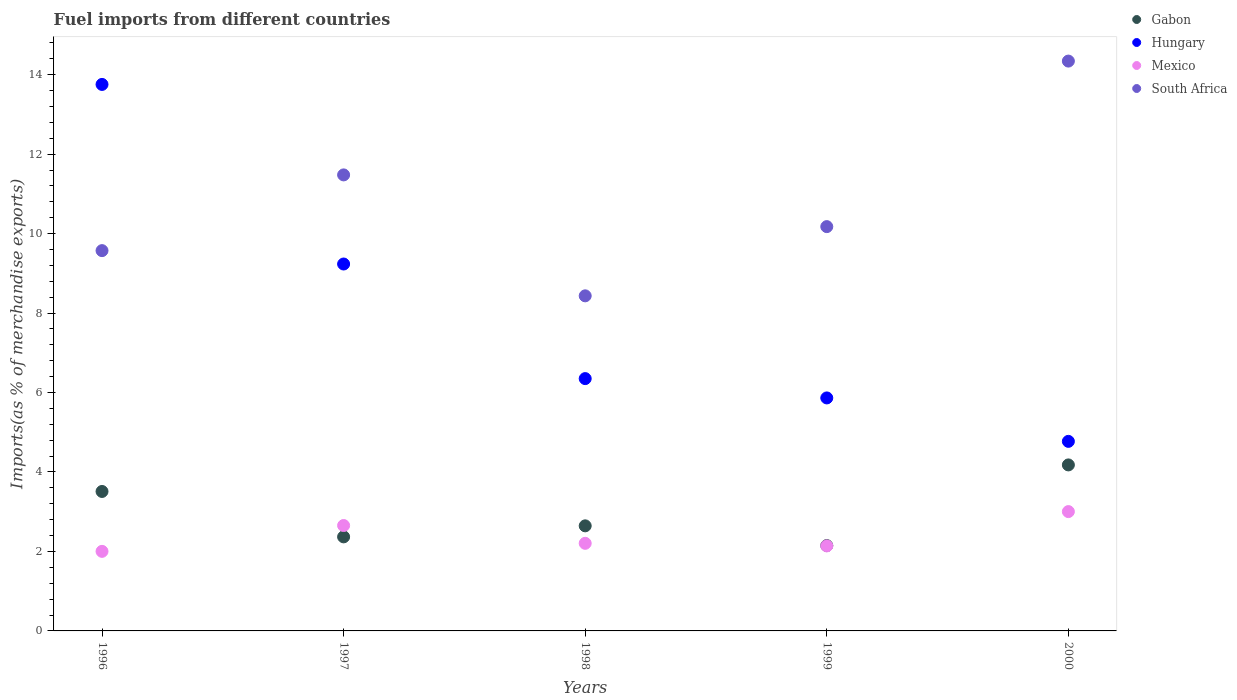Is the number of dotlines equal to the number of legend labels?
Your answer should be very brief. Yes. What is the percentage of imports to different countries in Gabon in 2000?
Offer a terse response. 4.18. Across all years, what is the maximum percentage of imports to different countries in Hungary?
Provide a short and direct response. 13.76. Across all years, what is the minimum percentage of imports to different countries in South Africa?
Make the answer very short. 8.43. What is the total percentage of imports to different countries in Mexico in the graph?
Offer a very short reply. 12. What is the difference between the percentage of imports to different countries in Mexico in 1996 and that in 1997?
Your answer should be compact. -0.65. What is the difference between the percentage of imports to different countries in Gabon in 1999 and the percentage of imports to different countries in Hungary in 2000?
Your answer should be compact. -2.62. What is the average percentage of imports to different countries in South Africa per year?
Ensure brevity in your answer.  10.8. In the year 2000, what is the difference between the percentage of imports to different countries in Mexico and percentage of imports to different countries in Hungary?
Ensure brevity in your answer.  -1.77. In how many years, is the percentage of imports to different countries in Gabon greater than 1.6 %?
Provide a succinct answer. 5. What is the ratio of the percentage of imports to different countries in Gabon in 1999 to that in 2000?
Your answer should be very brief. 0.51. What is the difference between the highest and the second highest percentage of imports to different countries in Gabon?
Offer a terse response. 0.67. What is the difference between the highest and the lowest percentage of imports to different countries in Gabon?
Provide a succinct answer. 2.03. In how many years, is the percentage of imports to different countries in South Africa greater than the average percentage of imports to different countries in South Africa taken over all years?
Provide a succinct answer. 2. Is the sum of the percentage of imports to different countries in Mexico in 1996 and 1998 greater than the maximum percentage of imports to different countries in Gabon across all years?
Offer a very short reply. Yes. Is it the case that in every year, the sum of the percentage of imports to different countries in Hungary and percentage of imports to different countries in South Africa  is greater than the sum of percentage of imports to different countries in Mexico and percentage of imports to different countries in Gabon?
Offer a very short reply. No. Is the percentage of imports to different countries in Mexico strictly less than the percentage of imports to different countries in Hungary over the years?
Your answer should be very brief. Yes. Are the values on the major ticks of Y-axis written in scientific E-notation?
Provide a short and direct response. No. Does the graph contain any zero values?
Provide a short and direct response. No. Does the graph contain grids?
Offer a very short reply. No. How are the legend labels stacked?
Ensure brevity in your answer.  Vertical. What is the title of the graph?
Provide a succinct answer. Fuel imports from different countries. What is the label or title of the Y-axis?
Give a very brief answer. Imports(as % of merchandise exports). What is the Imports(as % of merchandise exports) of Gabon in 1996?
Provide a short and direct response. 3.51. What is the Imports(as % of merchandise exports) of Hungary in 1996?
Your answer should be very brief. 13.76. What is the Imports(as % of merchandise exports) in Mexico in 1996?
Provide a short and direct response. 2. What is the Imports(as % of merchandise exports) of South Africa in 1996?
Make the answer very short. 9.57. What is the Imports(as % of merchandise exports) in Gabon in 1997?
Provide a succinct answer. 2.37. What is the Imports(as % of merchandise exports) in Hungary in 1997?
Make the answer very short. 9.24. What is the Imports(as % of merchandise exports) in Mexico in 1997?
Ensure brevity in your answer.  2.65. What is the Imports(as % of merchandise exports) of South Africa in 1997?
Provide a short and direct response. 11.48. What is the Imports(as % of merchandise exports) in Gabon in 1998?
Keep it short and to the point. 2.64. What is the Imports(as % of merchandise exports) in Hungary in 1998?
Your response must be concise. 6.35. What is the Imports(as % of merchandise exports) in Mexico in 1998?
Your answer should be very brief. 2.2. What is the Imports(as % of merchandise exports) of South Africa in 1998?
Provide a short and direct response. 8.43. What is the Imports(as % of merchandise exports) of Gabon in 1999?
Offer a terse response. 2.15. What is the Imports(as % of merchandise exports) in Hungary in 1999?
Your answer should be very brief. 5.86. What is the Imports(as % of merchandise exports) in Mexico in 1999?
Your answer should be compact. 2.14. What is the Imports(as % of merchandise exports) in South Africa in 1999?
Make the answer very short. 10.18. What is the Imports(as % of merchandise exports) of Gabon in 2000?
Offer a very short reply. 4.18. What is the Imports(as % of merchandise exports) in Hungary in 2000?
Your answer should be very brief. 4.77. What is the Imports(as % of merchandise exports) of Mexico in 2000?
Make the answer very short. 3. What is the Imports(as % of merchandise exports) in South Africa in 2000?
Offer a very short reply. 14.34. Across all years, what is the maximum Imports(as % of merchandise exports) in Gabon?
Your answer should be compact. 4.18. Across all years, what is the maximum Imports(as % of merchandise exports) of Hungary?
Keep it short and to the point. 13.76. Across all years, what is the maximum Imports(as % of merchandise exports) in Mexico?
Make the answer very short. 3. Across all years, what is the maximum Imports(as % of merchandise exports) of South Africa?
Your answer should be very brief. 14.34. Across all years, what is the minimum Imports(as % of merchandise exports) of Gabon?
Keep it short and to the point. 2.15. Across all years, what is the minimum Imports(as % of merchandise exports) in Hungary?
Your answer should be compact. 4.77. Across all years, what is the minimum Imports(as % of merchandise exports) of Mexico?
Keep it short and to the point. 2. Across all years, what is the minimum Imports(as % of merchandise exports) in South Africa?
Offer a very short reply. 8.43. What is the total Imports(as % of merchandise exports) in Gabon in the graph?
Provide a short and direct response. 14.85. What is the total Imports(as % of merchandise exports) in Hungary in the graph?
Ensure brevity in your answer.  39.98. What is the total Imports(as % of merchandise exports) of Mexico in the graph?
Offer a very short reply. 12. What is the total Imports(as % of merchandise exports) of South Africa in the graph?
Keep it short and to the point. 54. What is the difference between the Imports(as % of merchandise exports) of Gabon in 1996 and that in 1997?
Make the answer very short. 1.14. What is the difference between the Imports(as % of merchandise exports) in Hungary in 1996 and that in 1997?
Your answer should be compact. 4.52. What is the difference between the Imports(as % of merchandise exports) of Mexico in 1996 and that in 1997?
Ensure brevity in your answer.  -0.65. What is the difference between the Imports(as % of merchandise exports) of South Africa in 1996 and that in 1997?
Give a very brief answer. -1.91. What is the difference between the Imports(as % of merchandise exports) of Gabon in 1996 and that in 1998?
Provide a succinct answer. 0.87. What is the difference between the Imports(as % of merchandise exports) in Hungary in 1996 and that in 1998?
Offer a very short reply. 7.4. What is the difference between the Imports(as % of merchandise exports) of Mexico in 1996 and that in 1998?
Your answer should be compact. -0.2. What is the difference between the Imports(as % of merchandise exports) of South Africa in 1996 and that in 1998?
Make the answer very short. 1.14. What is the difference between the Imports(as % of merchandise exports) of Gabon in 1996 and that in 1999?
Give a very brief answer. 1.36. What is the difference between the Imports(as % of merchandise exports) of Hungary in 1996 and that in 1999?
Your answer should be very brief. 7.89. What is the difference between the Imports(as % of merchandise exports) in Mexico in 1996 and that in 1999?
Your answer should be very brief. -0.14. What is the difference between the Imports(as % of merchandise exports) of South Africa in 1996 and that in 1999?
Offer a terse response. -0.6. What is the difference between the Imports(as % of merchandise exports) in Gabon in 1996 and that in 2000?
Offer a terse response. -0.67. What is the difference between the Imports(as % of merchandise exports) in Hungary in 1996 and that in 2000?
Offer a very short reply. 8.98. What is the difference between the Imports(as % of merchandise exports) of Mexico in 1996 and that in 2000?
Provide a short and direct response. -1. What is the difference between the Imports(as % of merchandise exports) of South Africa in 1996 and that in 2000?
Provide a succinct answer. -4.77. What is the difference between the Imports(as % of merchandise exports) in Gabon in 1997 and that in 1998?
Keep it short and to the point. -0.28. What is the difference between the Imports(as % of merchandise exports) in Hungary in 1997 and that in 1998?
Offer a terse response. 2.88. What is the difference between the Imports(as % of merchandise exports) of Mexico in 1997 and that in 1998?
Make the answer very short. 0.45. What is the difference between the Imports(as % of merchandise exports) of South Africa in 1997 and that in 1998?
Offer a very short reply. 3.04. What is the difference between the Imports(as % of merchandise exports) in Gabon in 1997 and that in 1999?
Your answer should be very brief. 0.22. What is the difference between the Imports(as % of merchandise exports) in Hungary in 1997 and that in 1999?
Give a very brief answer. 3.37. What is the difference between the Imports(as % of merchandise exports) of Mexico in 1997 and that in 1999?
Make the answer very short. 0.51. What is the difference between the Imports(as % of merchandise exports) of South Africa in 1997 and that in 1999?
Make the answer very short. 1.3. What is the difference between the Imports(as % of merchandise exports) in Gabon in 1997 and that in 2000?
Make the answer very short. -1.81. What is the difference between the Imports(as % of merchandise exports) in Hungary in 1997 and that in 2000?
Make the answer very short. 4.46. What is the difference between the Imports(as % of merchandise exports) in Mexico in 1997 and that in 2000?
Your response must be concise. -0.35. What is the difference between the Imports(as % of merchandise exports) of South Africa in 1997 and that in 2000?
Make the answer very short. -2.86. What is the difference between the Imports(as % of merchandise exports) in Gabon in 1998 and that in 1999?
Offer a very short reply. 0.5. What is the difference between the Imports(as % of merchandise exports) of Hungary in 1998 and that in 1999?
Offer a terse response. 0.49. What is the difference between the Imports(as % of merchandise exports) of Mexico in 1998 and that in 1999?
Provide a short and direct response. 0.07. What is the difference between the Imports(as % of merchandise exports) of South Africa in 1998 and that in 1999?
Your answer should be compact. -1.74. What is the difference between the Imports(as % of merchandise exports) in Gabon in 1998 and that in 2000?
Offer a terse response. -1.53. What is the difference between the Imports(as % of merchandise exports) in Hungary in 1998 and that in 2000?
Offer a terse response. 1.58. What is the difference between the Imports(as % of merchandise exports) of Mexico in 1998 and that in 2000?
Provide a short and direct response. -0.8. What is the difference between the Imports(as % of merchandise exports) in South Africa in 1998 and that in 2000?
Make the answer very short. -5.91. What is the difference between the Imports(as % of merchandise exports) of Gabon in 1999 and that in 2000?
Provide a short and direct response. -2.03. What is the difference between the Imports(as % of merchandise exports) in Hungary in 1999 and that in 2000?
Provide a succinct answer. 1.09. What is the difference between the Imports(as % of merchandise exports) in Mexico in 1999 and that in 2000?
Give a very brief answer. -0.86. What is the difference between the Imports(as % of merchandise exports) of South Africa in 1999 and that in 2000?
Offer a terse response. -4.17. What is the difference between the Imports(as % of merchandise exports) of Gabon in 1996 and the Imports(as % of merchandise exports) of Hungary in 1997?
Your response must be concise. -5.72. What is the difference between the Imports(as % of merchandise exports) of Gabon in 1996 and the Imports(as % of merchandise exports) of Mexico in 1997?
Ensure brevity in your answer.  0.86. What is the difference between the Imports(as % of merchandise exports) of Gabon in 1996 and the Imports(as % of merchandise exports) of South Africa in 1997?
Provide a succinct answer. -7.97. What is the difference between the Imports(as % of merchandise exports) of Hungary in 1996 and the Imports(as % of merchandise exports) of Mexico in 1997?
Your answer should be very brief. 11.1. What is the difference between the Imports(as % of merchandise exports) of Hungary in 1996 and the Imports(as % of merchandise exports) of South Africa in 1997?
Provide a succinct answer. 2.28. What is the difference between the Imports(as % of merchandise exports) of Mexico in 1996 and the Imports(as % of merchandise exports) of South Africa in 1997?
Offer a terse response. -9.48. What is the difference between the Imports(as % of merchandise exports) of Gabon in 1996 and the Imports(as % of merchandise exports) of Hungary in 1998?
Ensure brevity in your answer.  -2.84. What is the difference between the Imports(as % of merchandise exports) of Gabon in 1996 and the Imports(as % of merchandise exports) of Mexico in 1998?
Your response must be concise. 1.31. What is the difference between the Imports(as % of merchandise exports) in Gabon in 1996 and the Imports(as % of merchandise exports) in South Africa in 1998?
Keep it short and to the point. -4.92. What is the difference between the Imports(as % of merchandise exports) in Hungary in 1996 and the Imports(as % of merchandise exports) in Mexico in 1998?
Offer a very short reply. 11.55. What is the difference between the Imports(as % of merchandise exports) of Hungary in 1996 and the Imports(as % of merchandise exports) of South Africa in 1998?
Ensure brevity in your answer.  5.32. What is the difference between the Imports(as % of merchandise exports) in Mexico in 1996 and the Imports(as % of merchandise exports) in South Africa in 1998?
Your answer should be very brief. -6.43. What is the difference between the Imports(as % of merchandise exports) in Gabon in 1996 and the Imports(as % of merchandise exports) in Hungary in 1999?
Keep it short and to the point. -2.35. What is the difference between the Imports(as % of merchandise exports) in Gabon in 1996 and the Imports(as % of merchandise exports) in Mexico in 1999?
Your answer should be compact. 1.37. What is the difference between the Imports(as % of merchandise exports) of Gabon in 1996 and the Imports(as % of merchandise exports) of South Africa in 1999?
Provide a short and direct response. -6.67. What is the difference between the Imports(as % of merchandise exports) in Hungary in 1996 and the Imports(as % of merchandise exports) in Mexico in 1999?
Keep it short and to the point. 11.62. What is the difference between the Imports(as % of merchandise exports) in Hungary in 1996 and the Imports(as % of merchandise exports) in South Africa in 1999?
Provide a short and direct response. 3.58. What is the difference between the Imports(as % of merchandise exports) in Mexico in 1996 and the Imports(as % of merchandise exports) in South Africa in 1999?
Make the answer very short. -8.17. What is the difference between the Imports(as % of merchandise exports) in Gabon in 1996 and the Imports(as % of merchandise exports) in Hungary in 2000?
Make the answer very short. -1.26. What is the difference between the Imports(as % of merchandise exports) in Gabon in 1996 and the Imports(as % of merchandise exports) in Mexico in 2000?
Provide a succinct answer. 0.51. What is the difference between the Imports(as % of merchandise exports) in Gabon in 1996 and the Imports(as % of merchandise exports) in South Africa in 2000?
Ensure brevity in your answer.  -10.83. What is the difference between the Imports(as % of merchandise exports) of Hungary in 1996 and the Imports(as % of merchandise exports) of Mexico in 2000?
Ensure brevity in your answer.  10.75. What is the difference between the Imports(as % of merchandise exports) in Hungary in 1996 and the Imports(as % of merchandise exports) in South Africa in 2000?
Your response must be concise. -0.59. What is the difference between the Imports(as % of merchandise exports) of Mexico in 1996 and the Imports(as % of merchandise exports) of South Africa in 2000?
Offer a very short reply. -12.34. What is the difference between the Imports(as % of merchandise exports) in Gabon in 1997 and the Imports(as % of merchandise exports) in Hungary in 1998?
Your answer should be compact. -3.98. What is the difference between the Imports(as % of merchandise exports) in Gabon in 1997 and the Imports(as % of merchandise exports) in Mexico in 1998?
Keep it short and to the point. 0.16. What is the difference between the Imports(as % of merchandise exports) of Gabon in 1997 and the Imports(as % of merchandise exports) of South Africa in 1998?
Make the answer very short. -6.07. What is the difference between the Imports(as % of merchandise exports) of Hungary in 1997 and the Imports(as % of merchandise exports) of Mexico in 1998?
Your response must be concise. 7.03. What is the difference between the Imports(as % of merchandise exports) in Hungary in 1997 and the Imports(as % of merchandise exports) in South Africa in 1998?
Keep it short and to the point. 0.8. What is the difference between the Imports(as % of merchandise exports) of Mexico in 1997 and the Imports(as % of merchandise exports) of South Africa in 1998?
Your answer should be very brief. -5.78. What is the difference between the Imports(as % of merchandise exports) of Gabon in 1997 and the Imports(as % of merchandise exports) of Hungary in 1999?
Keep it short and to the point. -3.5. What is the difference between the Imports(as % of merchandise exports) in Gabon in 1997 and the Imports(as % of merchandise exports) in Mexico in 1999?
Give a very brief answer. 0.23. What is the difference between the Imports(as % of merchandise exports) of Gabon in 1997 and the Imports(as % of merchandise exports) of South Africa in 1999?
Make the answer very short. -7.81. What is the difference between the Imports(as % of merchandise exports) in Hungary in 1997 and the Imports(as % of merchandise exports) in Mexico in 1999?
Keep it short and to the point. 7.1. What is the difference between the Imports(as % of merchandise exports) in Hungary in 1997 and the Imports(as % of merchandise exports) in South Africa in 1999?
Your answer should be compact. -0.94. What is the difference between the Imports(as % of merchandise exports) in Mexico in 1997 and the Imports(as % of merchandise exports) in South Africa in 1999?
Offer a very short reply. -7.52. What is the difference between the Imports(as % of merchandise exports) of Gabon in 1997 and the Imports(as % of merchandise exports) of Hungary in 2000?
Ensure brevity in your answer.  -2.4. What is the difference between the Imports(as % of merchandise exports) in Gabon in 1997 and the Imports(as % of merchandise exports) in Mexico in 2000?
Provide a succinct answer. -0.64. What is the difference between the Imports(as % of merchandise exports) in Gabon in 1997 and the Imports(as % of merchandise exports) in South Africa in 2000?
Your answer should be very brief. -11.98. What is the difference between the Imports(as % of merchandise exports) in Hungary in 1997 and the Imports(as % of merchandise exports) in Mexico in 2000?
Your response must be concise. 6.23. What is the difference between the Imports(as % of merchandise exports) of Hungary in 1997 and the Imports(as % of merchandise exports) of South Africa in 2000?
Provide a succinct answer. -5.11. What is the difference between the Imports(as % of merchandise exports) of Mexico in 1997 and the Imports(as % of merchandise exports) of South Africa in 2000?
Provide a succinct answer. -11.69. What is the difference between the Imports(as % of merchandise exports) in Gabon in 1998 and the Imports(as % of merchandise exports) in Hungary in 1999?
Your answer should be very brief. -3.22. What is the difference between the Imports(as % of merchandise exports) of Gabon in 1998 and the Imports(as % of merchandise exports) of Mexico in 1999?
Ensure brevity in your answer.  0.51. What is the difference between the Imports(as % of merchandise exports) in Gabon in 1998 and the Imports(as % of merchandise exports) in South Africa in 1999?
Your answer should be compact. -7.53. What is the difference between the Imports(as % of merchandise exports) in Hungary in 1998 and the Imports(as % of merchandise exports) in Mexico in 1999?
Keep it short and to the point. 4.21. What is the difference between the Imports(as % of merchandise exports) in Hungary in 1998 and the Imports(as % of merchandise exports) in South Africa in 1999?
Keep it short and to the point. -3.83. What is the difference between the Imports(as % of merchandise exports) in Mexico in 1998 and the Imports(as % of merchandise exports) in South Africa in 1999?
Your response must be concise. -7.97. What is the difference between the Imports(as % of merchandise exports) in Gabon in 1998 and the Imports(as % of merchandise exports) in Hungary in 2000?
Keep it short and to the point. -2.13. What is the difference between the Imports(as % of merchandise exports) of Gabon in 1998 and the Imports(as % of merchandise exports) of Mexico in 2000?
Offer a terse response. -0.36. What is the difference between the Imports(as % of merchandise exports) of Gabon in 1998 and the Imports(as % of merchandise exports) of South Africa in 2000?
Ensure brevity in your answer.  -11.7. What is the difference between the Imports(as % of merchandise exports) of Hungary in 1998 and the Imports(as % of merchandise exports) of Mexico in 2000?
Offer a terse response. 3.35. What is the difference between the Imports(as % of merchandise exports) of Hungary in 1998 and the Imports(as % of merchandise exports) of South Africa in 2000?
Give a very brief answer. -7.99. What is the difference between the Imports(as % of merchandise exports) in Mexico in 1998 and the Imports(as % of merchandise exports) in South Africa in 2000?
Give a very brief answer. -12.14. What is the difference between the Imports(as % of merchandise exports) of Gabon in 1999 and the Imports(as % of merchandise exports) of Hungary in 2000?
Make the answer very short. -2.62. What is the difference between the Imports(as % of merchandise exports) in Gabon in 1999 and the Imports(as % of merchandise exports) in Mexico in 2000?
Keep it short and to the point. -0.86. What is the difference between the Imports(as % of merchandise exports) in Gabon in 1999 and the Imports(as % of merchandise exports) in South Africa in 2000?
Your answer should be very brief. -12.19. What is the difference between the Imports(as % of merchandise exports) in Hungary in 1999 and the Imports(as % of merchandise exports) in Mexico in 2000?
Ensure brevity in your answer.  2.86. What is the difference between the Imports(as % of merchandise exports) in Hungary in 1999 and the Imports(as % of merchandise exports) in South Africa in 2000?
Make the answer very short. -8.48. What is the difference between the Imports(as % of merchandise exports) in Mexico in 1999 and the Imports(as % of merchandise exports) in South Africa in 2000?
Your answer should be compact. -12.2. What is the average Imports(as % of merchandise exports) of Gabon per year?
Provide a succinct answer. 2.97. What is the average Imports(as % of merchandise exports) of Hungary per year?
Your answer should be very brief. 8. What is the average Imports(as % of merchandise exports) of Mexico per year?
Keep it short and to the point. 2.4. What is the average Imports(as % of merchandise exports) in South Africa per year?
Provide a succinct answer. 10.8. In the year 1996, what is the difference between the Imports(as % of merchandise exports) of Gabon and Imports(as % of merchandise exports) of Hungary?
Ensure brevity in your answer.  -10.24. In the year 1996, what is the difference between the Imports(as % of merchandise exports) in Gabon and Imports(as % of merchandise exports) in Mexico?
Provide a short and direct response. 1.51. In the year 1996, what is the difference between the Imports(as % of merchandise exports) in Gabon and Imports(as % of merchandise exports) in South Africa?
Make the answer very short. -6.06. In the year 1996, what is the difference between the Imports(as % of merchandise exports) of Hungary and Imports(as % of merchandise exports) of Mexico?
Your answer should be compact. 11.75. In the year 1996, what is the difference between the Imports(as % of merchandise exports) in Hungary and Imports(as % of merchandise exports) in South Africa?
Your answer should be very brief. 4.18. In the year 1996, what is the difference between the Imports(as % of merchandise exports) of Mexico and Imports(as % of merchandise exports) of South Africa?
Offer a very short reply. -7.57. In the year 1997, what is the difference between the Imports(as % of merchandise exports) in Gabon and Imports(as % of merchandise exports) in Hungary?
Offer a very short reply. -6.87. In the year 1997, what is the difference between the Imports(as % of merchandise exports) in Gabon and Imports(as % of merchandise exports) in Mexico?
Ensure brevity in your answer.  -0.29. In the year 1997, what is the difference between the Imports(as % of merchandise exports) in Gabon and Imports(as % of merchandise exports) in South Africa?
Give a very brief answer. -9.11. In the year 1997, what is the difference between the Imports(as % of merchandise exports) of Hungary and Imports(as % of merchandise exports) of Mexico?
Offer a terse response. 6.58. In the year 1997, what is the difference between the Imports(as % of merchandise exports) in Hungary and Imports(as % of merchandise exports) in South Africa?
Your answer should be compact. -2.24. In the year 1997, what is the difference between the Imports(as % of merchandise exports) of Mexico and Imports(as % of merchandise exports) of South Africa?
Give a very brief answer. -8.82. In the year 1998, what is the difference between the Imports(as % of merchandise exports) of Gabon and Imports(as % of merchandise exports) of Hungary?
Ensure brevity in your answer.  -3.71. In the year 1998, what is the difference between the Imports(as % of merchandise exports) in Gabon and Imports(as % of merchandise exports) in Mexico?
Offer a very short reply. 0.44. In the year 1998, what is the difference between the Imports(as % of merchandise exports) in Gabon and Imports(as % of merchandise exports) in South Africa?
Your answer should be very brief. -5.79. In the year 1998, what is the difference between the Imports(as % of merchandise exports) in Hungary and Imports(as % of merchandise exports) in Mexico?
Ensure brevity in your answer.  4.15. In the year 1998, what is the difference between the Imports(as % of merchandise exports) of Hungary and Imports(as % of merchandise exports) of South Africa?
Your response must be concise. -2.08. In the year 1998, what is the difference between the Imports(as % of merchandise exports) in Mexico and Imports(as % of merchandise exports) in South Africa?
Give a very brief answer. -6.23. In the year 1999, what is the difference between the Imports(as % of merchandise exports) in Gabon and Imports(as % of merchandise exports) in Hungary?
Your answer should be compact. -3.72. In the year 1999, what is the difference between the Imports(as % of merchandise exports) of Gabon and Imports(as % of merchandise exports) of Mexico?
Your answer should be compact. 0.01. In the year 1999, what is the difference between the Imports(as % of merchandise exports) in Gabon and Imports(as % of merchandise exports) in South Africa?
Make the answer very short. -8.03. In the year 1999, what is the difference between the Imports(as % of merchandise exports) in Hungary and Imports(as % of merchandise exports) in Mexico?
Offer a terse response. 3.72. In the year 1999, what is the difference between the Imports(as % of merchandise exports) in Hungary and Imports(as % of merchandise exports) in South Africa?
Offer a terse response. -4.31. In the year 1999, what is the difference between the Imports(as % of merchandise exports) in Mexico and Imports(as % of merchandise exports) in South Africa?
Your answer should be very brief. -8.04. In the year 2000, what is the difference between the Imports(as % of merchandise exports) of Gabon and Imports(as % of merchandise exports) of Hungary?
Offer a very short reply. -0.59. In the year 2000, what is the difference between the Imports(as % of merchandise exports) in Gabon and Imports(as % of merchandise exports) in Mexico?
Your answer should be compact. 1.17. In the year 2000, what is the difference between the Imports(as % of merchandise exports) of Gabon and Imports(as % of merchandise exports) of South Africa?
Your response must be concise. -10.16. In the year 2000, what is the difference between the Imports(as % of merchandise exports) in Hungary and Imports(as % of merchandise exports) in Mexico?
Make the answer very short. 1.77. In the year 2000, what is the difference between the Imports(as % of merchandise exports) in Hungary and Imports(as % of merchandise exports) in South Africa?
Offer a terse response. -9.57. In the year 2000, what is the difference between the Imports(as % of merchandise exports) in Mexico and Imports(as % of merchandise exports) in South Africa?
Your response must be concise. -11.34. What is the ratio of the Imports(as % of merchandise exports) in Gabon in 1996 to that in 1997?
Your response must be concise. 1.48. What is the ratio of the Imports(as % of merchandise exports) in Hungary in 1996 to that in 1997?
Offer a very short reply. 1.49. What is the ratio of the Imports(as % of merchandise exports) of Mexico in 1996 to that in 1997?
Your response must be concise. 0.75. What is the ratio of the Imports(as % of merchandise exports) of South Africa in 1996 to that in 1997?
Your answer should be very brief. 0.83. What is the ratio of the Imports(as % of merchandise exports) of Gabon in 1996 to that in 1998?
Make the answer very short. 1.33. What is the ratio of the Imports(as % of merchandise exports) of Hungary in 1996 to that in 1998?
Your response must be concise. 2.17. What is the ratio of the Imports(as % of merchandise exports) of Mexico in 1996 to that in 1998?
Ensure brevity in your answer.  0.91. What is the ratio of the Imports(as % of merchandise exports) of South Africa in 1996 to that in 1998?
Keep it short and to the point. 1.13. What is the ratio of the Imports(as % of merchandise exports) in Gabon in 1996 to that in 1999?
Keep it short and to the point. 1.63. What is the ratio of the Imports(as % of merchandise exports) in Hungary in 1996 to that in 1999?
Keep it short and to the point. 2.35. What is the ratio of the Imports(as % of merchandise exports) in Mexico in 1996 to that in 1999?
Your answer should be very brief. 0.94. What is the ratio of the Imports(as % of merchandise exports) of South Africa in 1996 to that in 1999?
Your answer should be compact. 0.94. What is the ratio of the Imports(as % of merchandise exports) of Gabon in 1996 to that in 2000?
Keep it short and to the point. 0.84. What is the ratio of the Imports(as % of merchandise exports) in Hungary in 1996 to that in 2000?
Your answer should be compact. 2.88. What is the ratio of the Imports(as % of merchandise exports) in Mexico in 1996 to that in 2000?
Ensure brevity in your answer.  0.67. What is the ratio of the Imports(as % of merchandise exports) in South Africa in 1996 to that in 2000?
Keep it short and to the point. 0.67. What is the ratio of the Imports(as % of merchandise exports) of Gabon in 1997 to that in 1998?
Your response must be concise. 0.9. What is the ratio of the Imports(as % of merchandise exports) of Hungary in 1997 to that in 1998?
Provide a succinct answer. 1.45. What is the ratio of the Imports(as % of merchandise exports) in Mexico in 1997 to that in 1998?
Offer a terse response. 1.2. What is the ratio of the Imports(as % of merchandise exports) in South Africa in 1997 to that in 1998?
Offer a very short reply. 1.36. What is the ratio of the Imports(as % of merchandise exports) in Gabon in 1997 to that in 1999?
Your answer should be very brief. 1.1. What is the ratio of the Imports(as % of merchandise exports) of Hungary in 1997 to that in 1999?
Give a very brief answer. 1.57. What is the ratio of the Imports(as % of merchandise exports) in Mexico in 1997 to that in 1999?
Keep it short and to the point. 1.24. What is the ratio of the Imports(as % of merchandise exports) in South Africa in 1997 to that in 1999?
Your answer should be very brief. 1.13. What is the ratio of the Imports(as % of merchandise exports) in Gabon in 1997 to that in 2000?
Offer a very short reply. 0.57. What is the ratio of the Imports(as % of merchandise exports) of Hungary in 1997 to that in 2000?
Keep it short and to the point. 1.94. What is the ratio of the Imports(as % of merchandise exports) of Mexico in 1997 to that in 2000?
Ensure brevity in your answer.  0.88. What is the ratio of the Imports(as % of merchandise exports) in South Africa in 1997 to that in 2000?
Provide a succinct answer. 0.8. What is the ratio of the Imports(as % of merchandise exports) in Gabon in 1998 to that in 1999?
Provide a succinct answer. 1.23. What is the ratio of the Imports(as % of merchandise exports) in Hungary in 1998 to that in 1999?
Your answer should be very brief. 1.08. What is the ratio of the Imports(as % of merchandise exports) in Mexico in 1998 to that in 1999?
Offer a terse response. 1.03. What is the ratio of the Imports(as % of merchandise exports) in South Africa in 1998 to that in 1999?
Make the answer very short. 0.83. What is the ratio of the Imports(as % of merchandise exports) of Gabon in 1998 to that in 2000?
Offer a terse response. 0.63. What is the ratio of the Imports(as % of merchandise exports) in Hungary in 1998 to that in 2000?
Your answer should be very brief. 1.33. What is the ratio of the Imports(as % of merchandise exports) in Mexico in 1998 to that in 2000?
Provide a short and direct response. 0.73. What is the ratio of the Imports(as % of merchandise exports) in South Africa in 1998 to that in 2000?
Provide a succinct answer. 0.59. What is the ratio of the Imports(as % of merchandise exports) in Gabon in 1999 to that in 2000?
Offer a terse response. 0.51. What is the ratio of the Imports(as % of merchandise exports) of Hungary in 1999 to that in 2000?
Ensure brevity in your answer.  1.23. What is the ratio of the Imports(as % of merchandise exports) of Mexico in 1999 to that in 2000?
Provide a short and direct response. 0.71. What is the ratio of the Imports(as % of merchandise exports) in South Africa in 1999 to that in 2000?
Your answer should be very brief. 0.71. What is the difference between the highest and the second highest Imports(as % of merchandise exports) of Gabon?
Ensure brevity in your answer.  0.67. What is the difference between the highest and the second highest Imports(as % of merchandise exports) of Hungary?
Your answer should be compact. 4.52. What is the difference between the highest and the second highest Imports(as % of merchandise exports) of Mexico?
Make the answer very short. 0.35. What is the difference between the highest and the second highest Imports(as % of merchandise exports) of South Africa?
Ensure brevity in your answer.  2.86. What is the difference between the highest and the lowest Imports(as % of merchandise exports) of Gabon?
Make the answer very short. 2.03. What is the difference between the highest and the lowest Imports(as % of merchandise exports) of Hungary?
Provide a short and direct response. 8.98. What is the difference between the highest and the lowest Imports(as % of merchandise exports) of Mexico?
Your response must be concise. 1. What is the difference between the highest and the lowest Imports(as % of merchandise exports) of South Africa?
Offer a terse response. 5.91. 